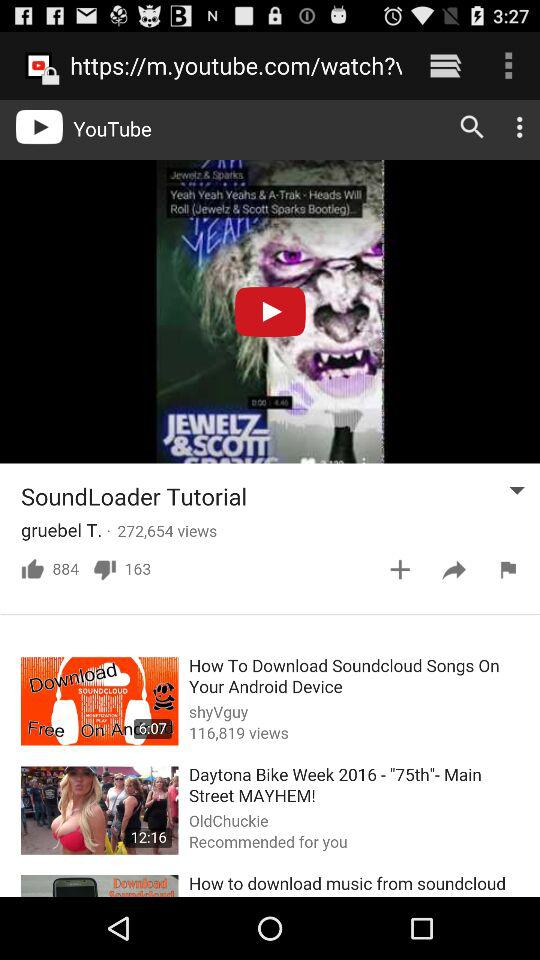How many people liked the SoundLoader tutorial? The SoundLoader tutorial is liked by 884 people. 